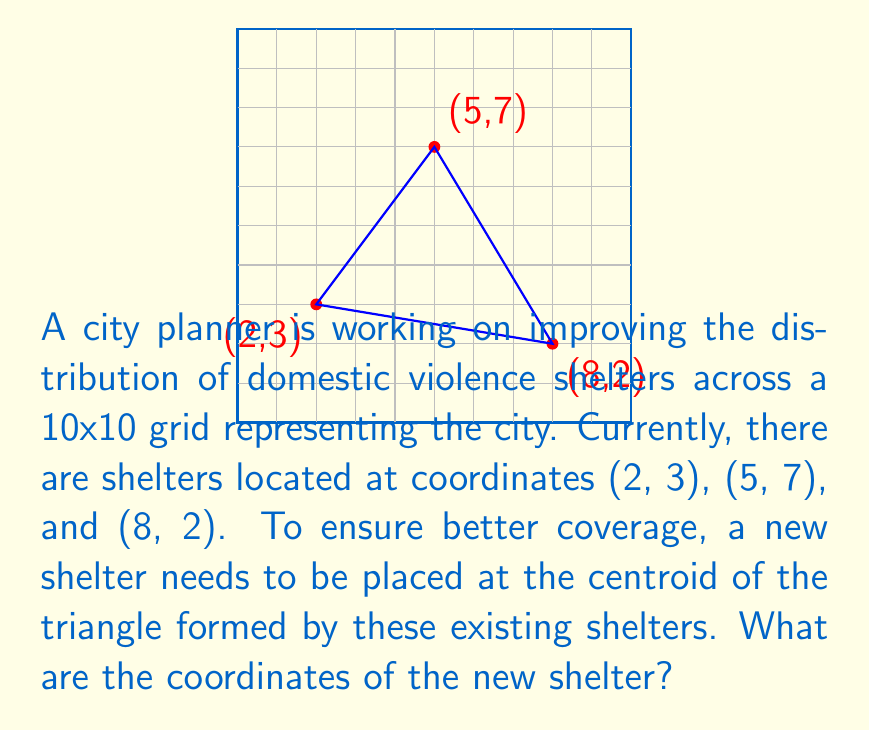Provide a solution to this math problem. To find the centroid of the triangle, we need to follow these steps:

1. The centroid of a triangle is located at the arithmetic mean of the coordinates of its vertices.

2. Let's define our vertices:
   A(2, 3), B(5, 7), C(8, 2)

3. To find the x-coordinate of the centroid:
   $$x = \frac{x_A + x_B + x_C}{3} = \frac{2 + 5 + 8}{3} = \frac{15}{3} = 5$$

4. To find the y-coordinate of the centroid:
   $$y = \frac{y_A + y_B + y_C}{3} = \frac{3 + 7 + 2}{3} = \frac{12}{3} = 4$$

5. Therefore, the coordinates of the centroid are (5, 4).

This location for the new shelter will provide a more balanced coverage of the city, potentially making it easier for victims of domestic violence to access help when needed.
Answer: (5, 4) 